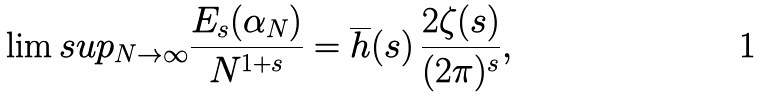<formula> <loc_0><loc_0><loc_500><loc_500>\lim s u p _ { N \rightarrow \infty } \frac { E _ { s } ( \alpha _ { N } ) } { N ^ { 1 + s } } = \overline { h } ( s ) \, \frac { 2 \zeta ( s ) } { ( 2 \pi ) ^ { s } } ,</formula> 